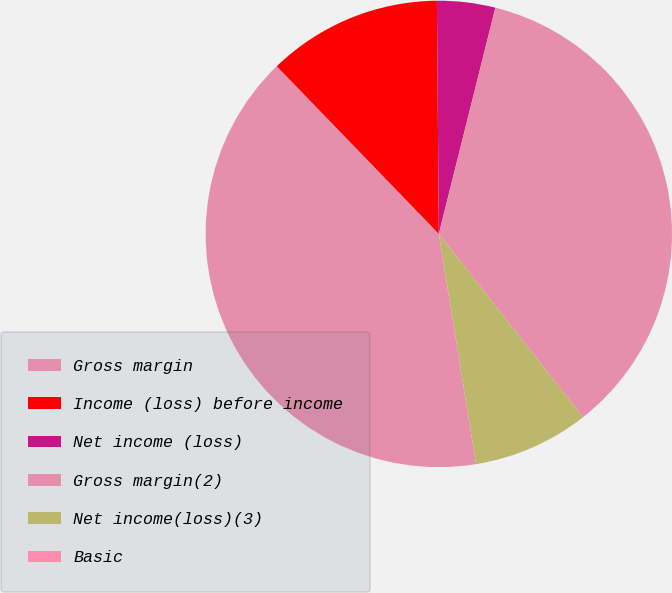<chart> <loc_0><loc_0><loc_500><loc_500><pie_chart><fcel>Gross margin<fcel>Income (loss) before income<fcel>Net income (loss)<fcel>Gross margin(2)<fcel>Net income(loss)(3)<fcel>Basic<nl><fcel>40.32%<fcel>12.1%<fcel>4.03%<fcel>35.49%<fcel>8.06%<fcel>0.0%<nl></chart> 